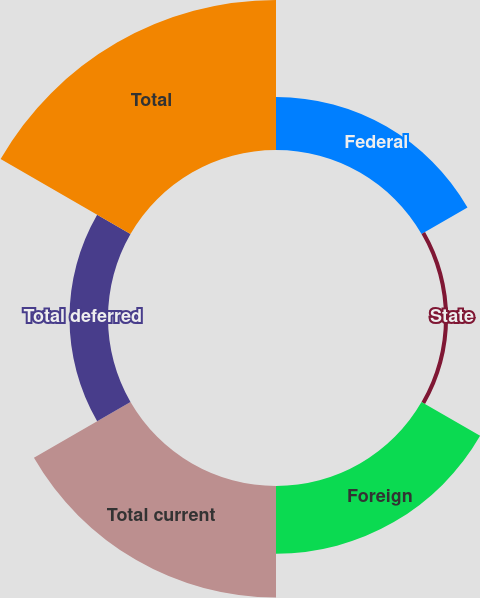<chart> <loc_0><loc_0><loc_500><loc_500><pie_chart><fcel>Federal<fcel>State<fcel>Foreign<fcel>Total current<fcel>Total deferred<fcel>Total<nl><fcel>12.5%<fcel>0.96%<fcel>15.93%<fcel>26.24%<fcel>9.06%<fcel>35.3%<nl></chart> 